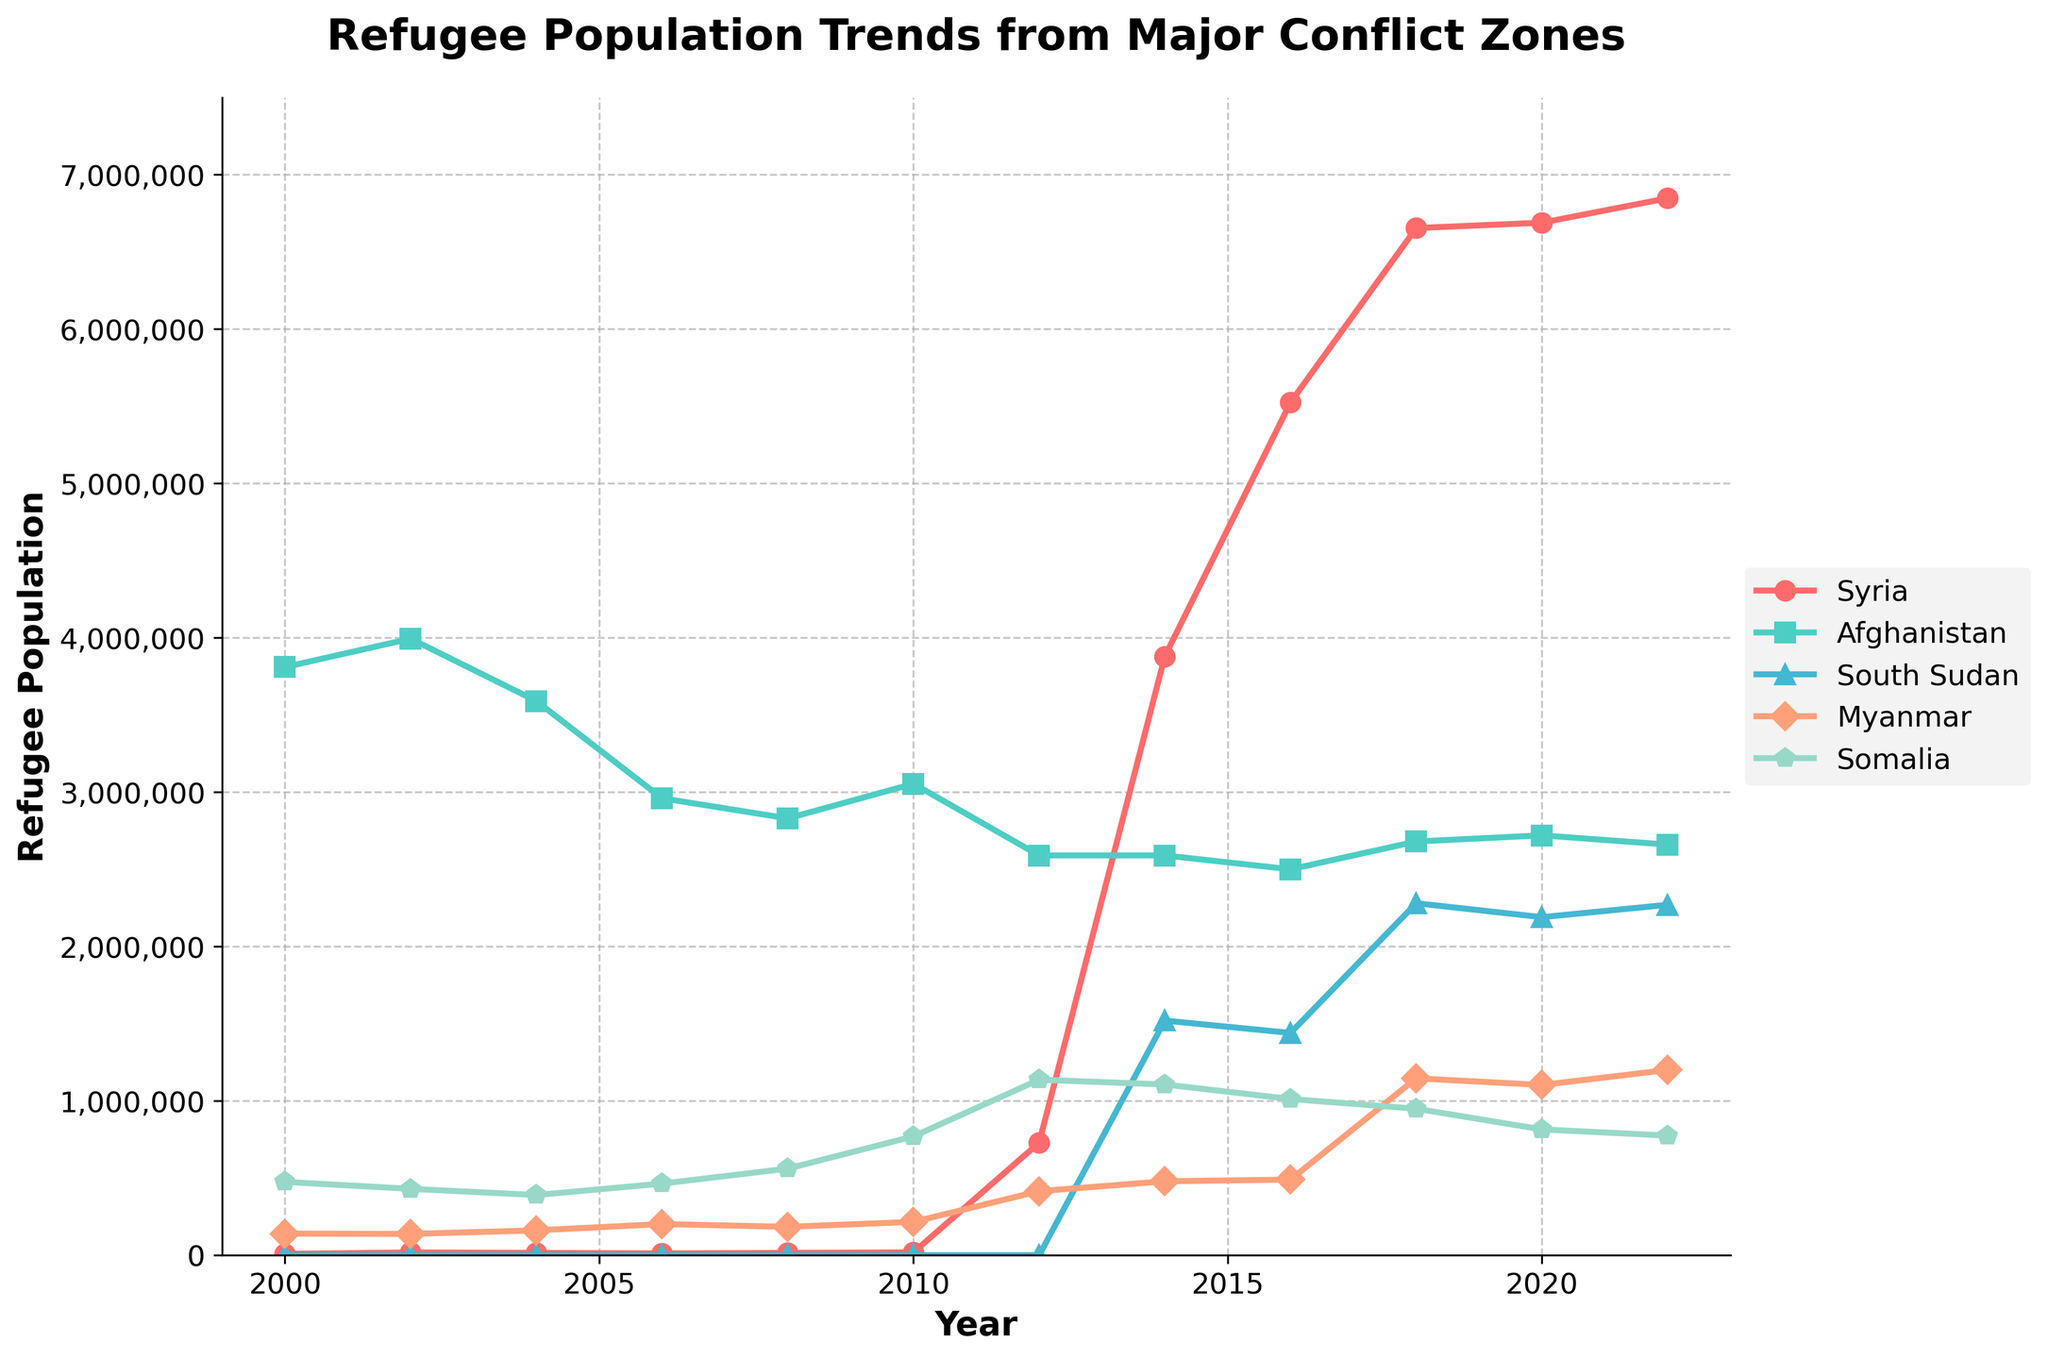Which country had the highest refugee population in 2018? By locating the data point for each country in the year 2018, we see that Syria had the highest refugee population in 2018, reaching over 6,654,000.
Answer: Syria Between 2010 and 2012, which country saw the largest absolute increase in the refugee population? We compare the difference between 2010 and 2012 for each country: Syria (729,000 - 18,500 = +710,500), Afghanistan (2,590,000 - 3,054,000 = -464,000), South Sudan (0), Myanmar (415,000 - 216,000 = +199,000), Somalia (1,137,000 - 770,000 = +367,000). Syria had the largest absolute increase in refugee population.
Answer: Syria Compare the trends of refugee population between Somalia and Myanmar from 2000 to 2022. Which country had more consistent growth? Somalia shows a generally increasing trend with fluctuations, whereas Myanmar's refugee numbers exhibit more consistent growth, particularly from 2006 onwards. Somalia has more noticeable ups and downs.
Answer: Myanmar What was the overall trend of the refugee population from Afghanistan between 2002 and 2016? Observing the line plot for Afghanistan from 2002 to 2016 shows a general downward trend from 3,994,000 to 2,500,000, indicating a decline in the refugee population.
Answer: Downward trend Identify the year when South Sudan's refugee population first appeared, and by how much did it increase in the first six years? South Sudan's refugee population first appears in 2014 with 1,520,000 refugees. By 2020, it increased to 2,190,000, so the increase is (2,190,000 - 1,520,000) = 670,000.
Answer: 2014, 670,000 What is the average refugee population of Syria from 2014 to 2022? Sum the refugee population for Syria from 2014 to 2022: 3,880,000 + 5,525,000 + 6,654,000 + 6,689,000 + 6,847,000 = 29,595,000. Divide by the number of years (2022-2014+1=9): 29,595,000 / 9 = 3,288,333.33.
Answer: 3,288,333 Which year did Somalia peak in the refugee population, and what was the value? Examining Somalia's line, the peak occurs in 2012, with a refugee population of 1,137,000.
Answer: 2012, 1,137,000 Are there any periods where the refugee population for Myanmar remained unchanged for two consecutive years? Observing Myanmar's data points, we see that from 2020 to 2022, the refugee population remains fairly stable around 1,103,000 to 1,200,000.
Answer: 2020-2022 